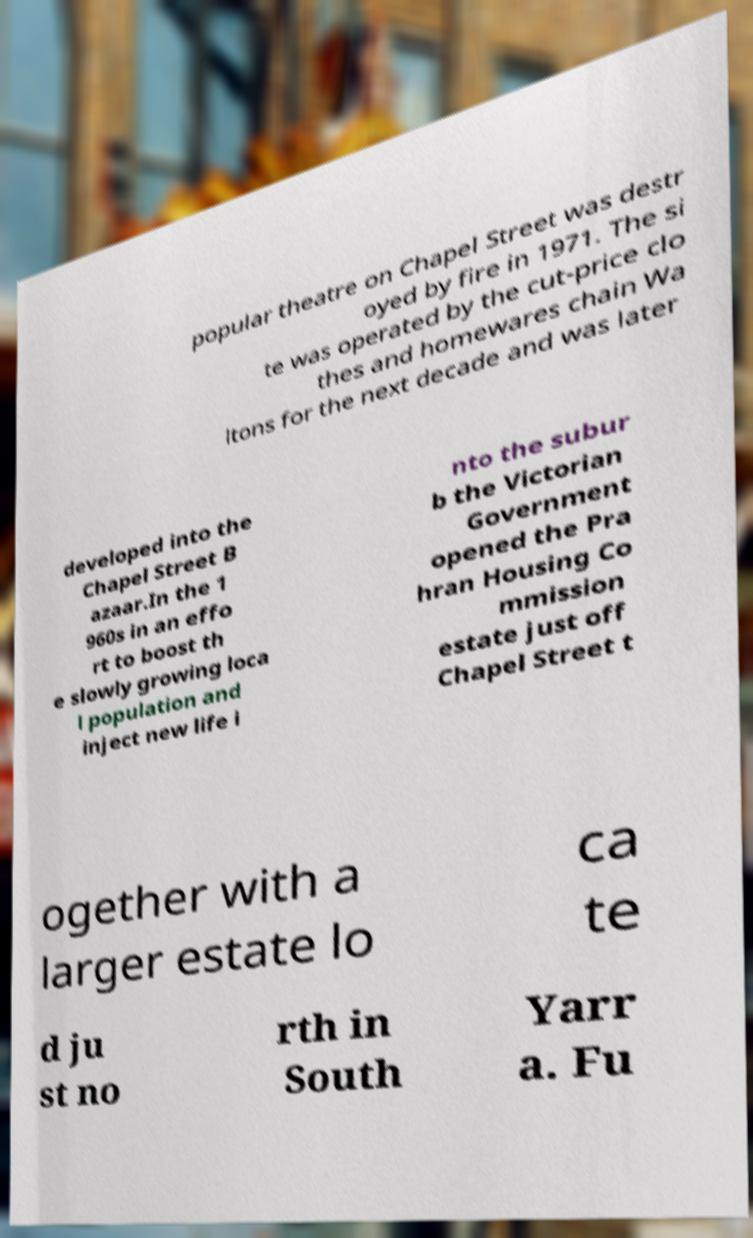What messages or text are displayed in this image? I need them in a readable, typed format. popular theatre on Chapel Street was destr oyed by fire in 1971. The si te was operated by the cut-price clo thes and homewares chain Wa ltons for the next decade and was later developed into the Chapel Street B azaar.In the 1 960s in an effo rt to boost th e slowly growing loca l population and inject new life i nto the subur b the Victorian Government opened the Pra hran Housing Co mmission estate just off Chapel Street t ogether with a larger estate lo ca te d ju st no rth in South Yarr a. Fu 